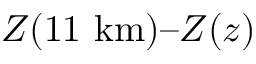Convert formula to latex. <formula><loc_0><loc_0><loc_500><loc_500>Z ( 1 1 \ k m ) Z ( z )</formula> 